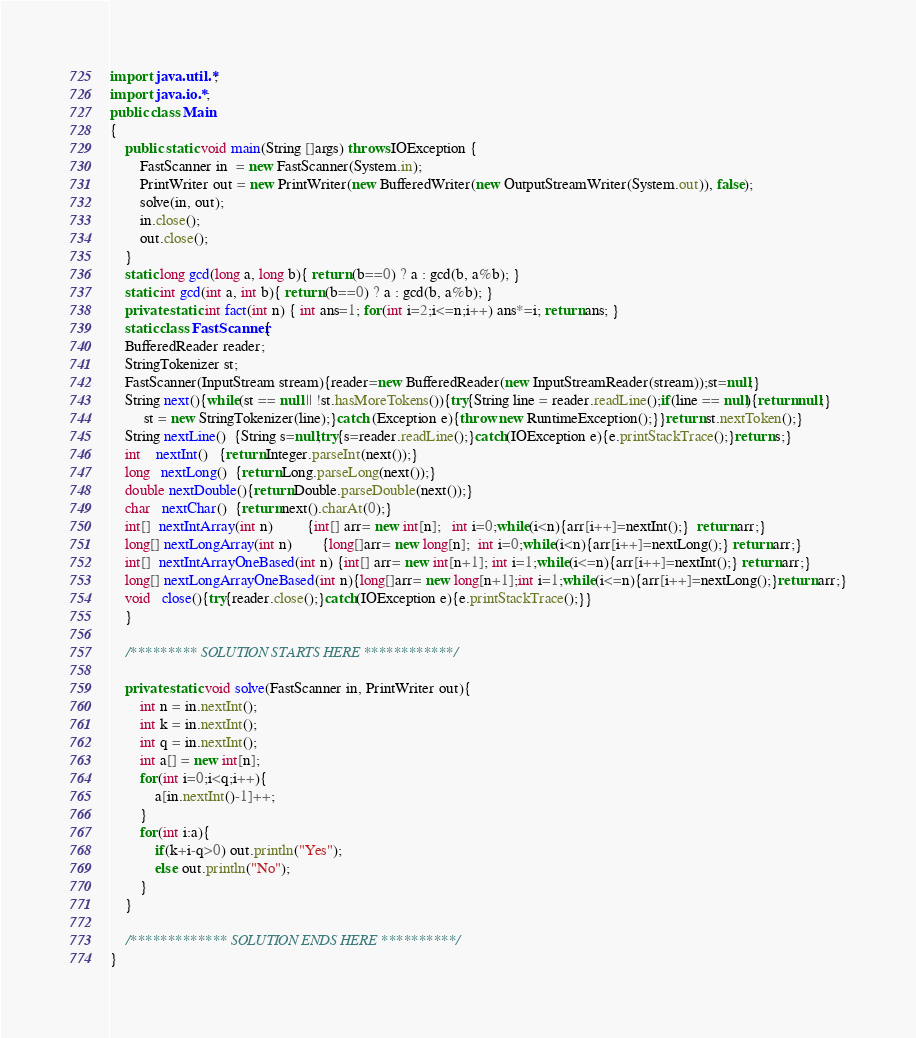Convert code to text. <code><loc_0><loc_0><loc_500><loc_500><_Java_>import java.util.*;
import java.io.*;
public class Main
{
    public static void main(String []args) throws IOException {
    	FastScanner in  = new FastScanner(System.in);
    	PrintWriter out = new PrintWriter(new BufferedWriter(new OutputStreamWriter(System.out)), false);
    	solve(in, out);
    	in.close();
    	out.close();
    }
    static long gcd(long a, long b){ return (b==0) ? a : gcd(b, a%b); }
    static int gcd(int a, int b){ return (b==0) ? a : gcd(b, a%b); }
    private static int fact(int n) { int ans=1; for(int i=2;i<=n;i++) ans*=i; return ans; }
    static class FastScanner{
	BufferedReader reader;
	StringTokenizer st;
	FastScanner(InputStream stream){reader=new BufferedReader(new InputStreamReader(stream));st=null;}
	String next(){while(st == null || !st.hasMoreTokens()){try{String line = reader.readLine();if(line == null){return null;}
	     st = new StringTokenizer(line);}catch (Exception e){throw new RuntimeException();}}return st.nextToken();}
	String nextLine()  {String s=null;try{s=reader.readLine();}catch(IOException e){e.printStackTrace();}return s;}
	int    nextInt()   {return Integer.parseInt(next());}
	long   nextLong()  {return Long.parseLong(next());}
	double nextDouble(){return Double.parseDouble(next());}
	char   nextChar()  {return next().charAt(0);}
	int[]  nextIntArray(int n)         {int[] arr= new int[n];   int i=0;while(i<n){arr[i++]=nextInt();}  return arr;}
	long[] nextLongArray(int n)        {long[]arr= new long[n];  int i=0;while(i<n){arr[i++]=nextLong();} return arr;}
	int[]  nextIntArrayOneBased(int n) {int[] arr= new int[n+1]; int i=1;while(i<=n){arr[i++]=nextInt();} return arr;}
	long[] nextLongArrayOneBased(int n){long[]arr= new long[n+1];int i=1;while(i<=n){arr[i++]=nextLong();}return arr;}
	void   close(){try{reader.close();}catch(IOException e){e.printStackTrace();}}
    }
    
    /********* SOLUTION STARTS HERE ************/
    
    private static void solve(FastScanner in, PrintWriter out){
        int n = in.nextInt();
        int k = in.nextInt();
        int q = in.nextInt();
        int a[] = new int[n];
        for(int i=0;i<q;i++){
            a[in.nextInt()-1]++;
        }
        for(int i:a){
            if(k+i-q>0) out.println("Yes");
            else out.println("No");
        }
    }
    
    /************* SOLUTION ENDS HERE **********/
}</code> 